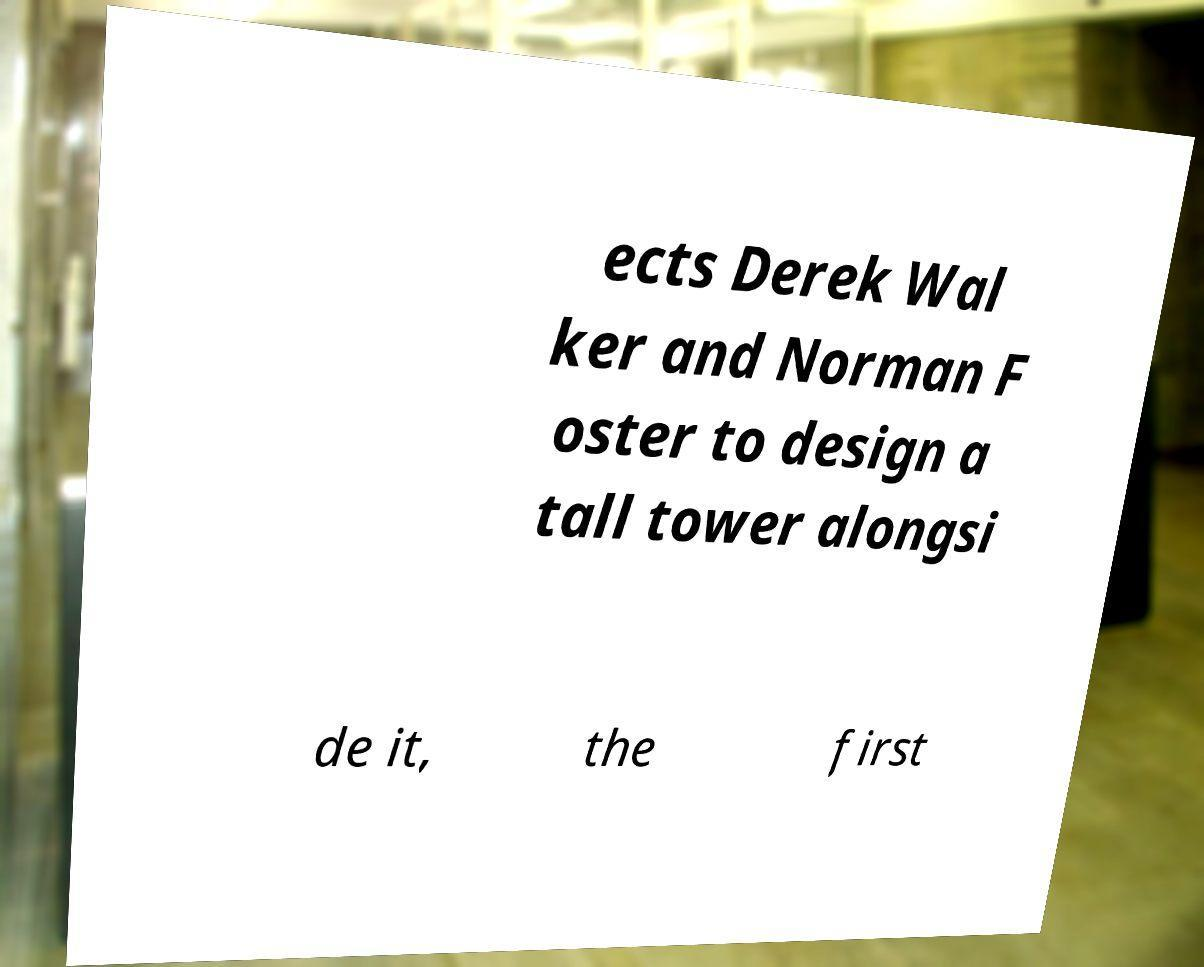Please read and relay the text visible in this image. What does it say? ects Derek Wal ker and Norman F oster to design a tall tower alongsi de it, the first 